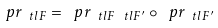Convert formula to latex. <formula><loc_0><loc_0><loc_500><loc_500>\ p r _ { \ t l { F } } = \ p r _ { \ t l { F } \ t l { F } ^ { \prime } } \circ \ p r _ { \ t l { F } ^ { \prime } }</formula> 